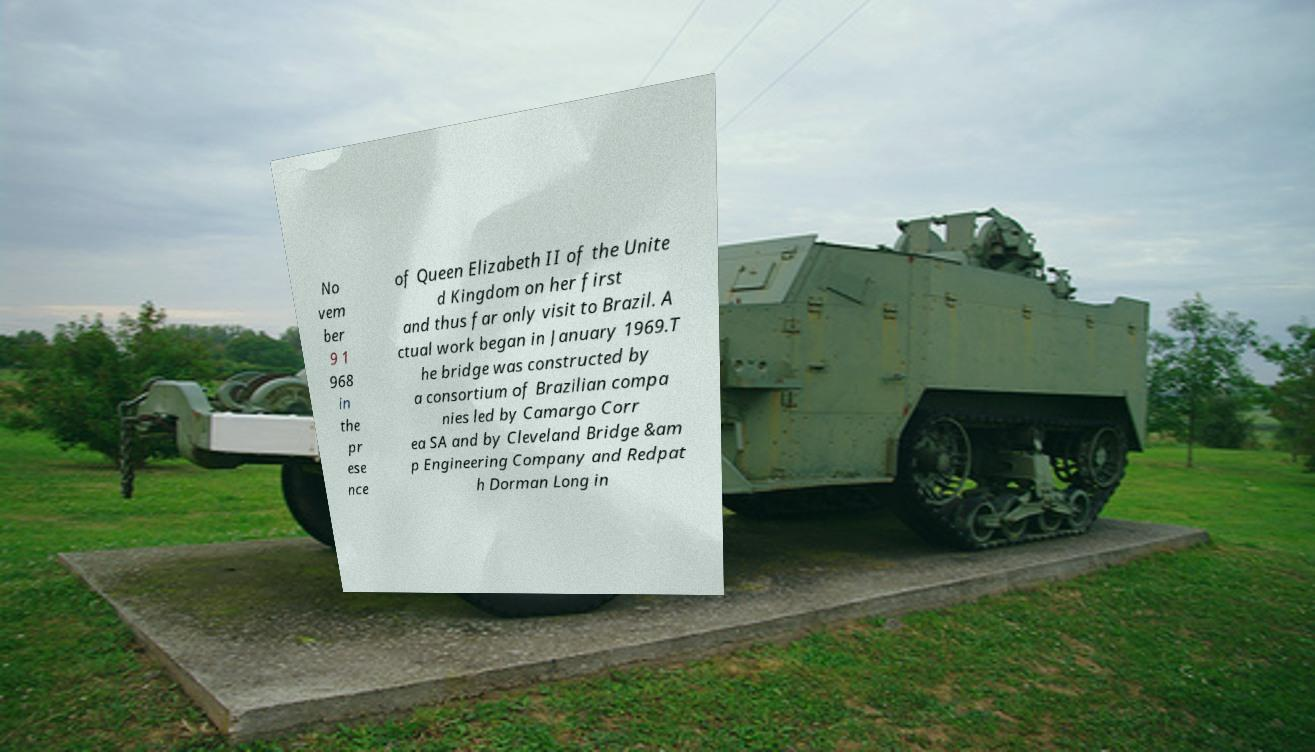Could you extract and type out the text from this image? No vem ber 9 1 968 in the pr ese nce of Queen Elizabeth II of the Unite d Kingdom on her first and thus far only visit to Brazil. A ctual work began in January 1969.T he bridge was constructed by a consortium of Brazilian compa nies led by Camargo Corr ea SA and by Cleveland Bridge &am p Engineering Company and Redpat h Dorman Long in 